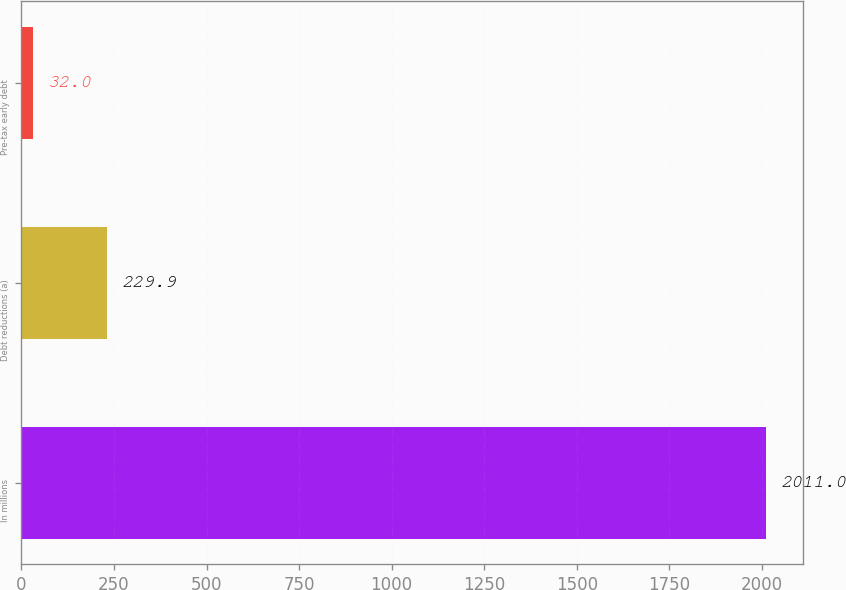Convert chart. <chart><loc_0><loc_0><loc_500><loc_500><bar_chart><fcel>In millions<fcel>Debt reductions (a)<fcel>Pre-tax early debt<nl><fcel>2011<fcel>229.9<fcel>32<nl></chart> 